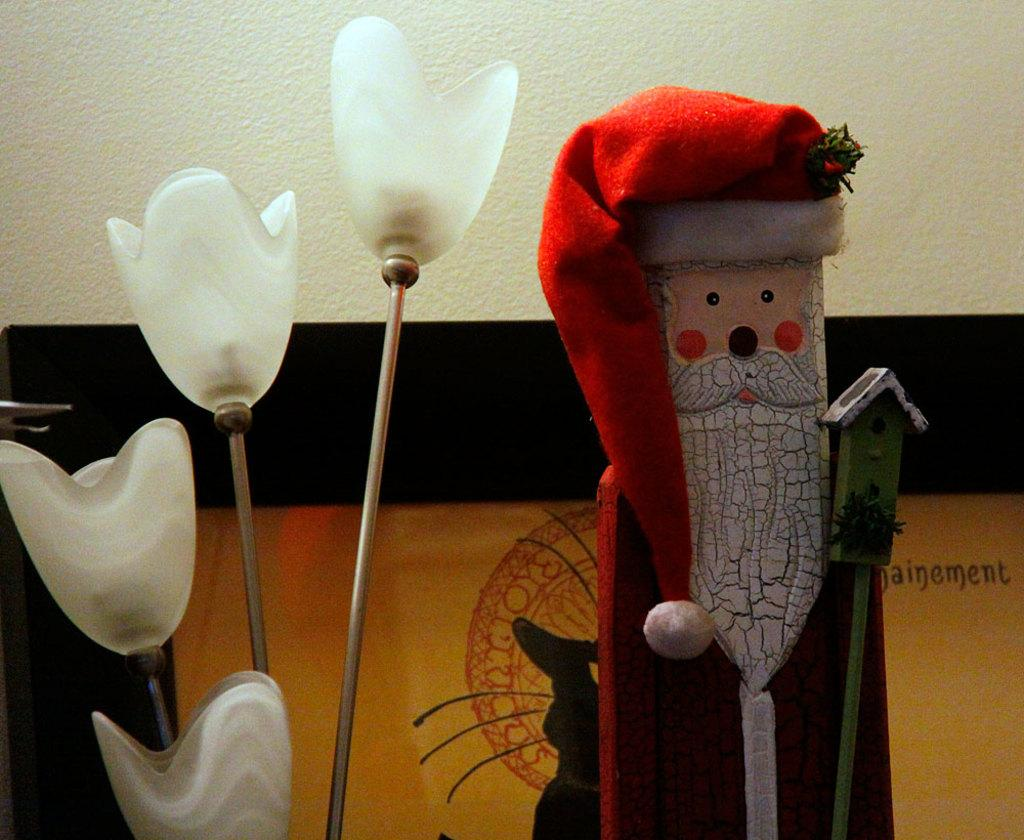What objects are in the foreground of the image? There are lights and a toy in the foreground of the image. What can be seen around the lights in the image? There is a frame visible in the image. What color is the wall at the top of the image? The wall at the top of the image is painted white. What learning rule is being taught in the image? There is no learning rule or educational content present in the image. 